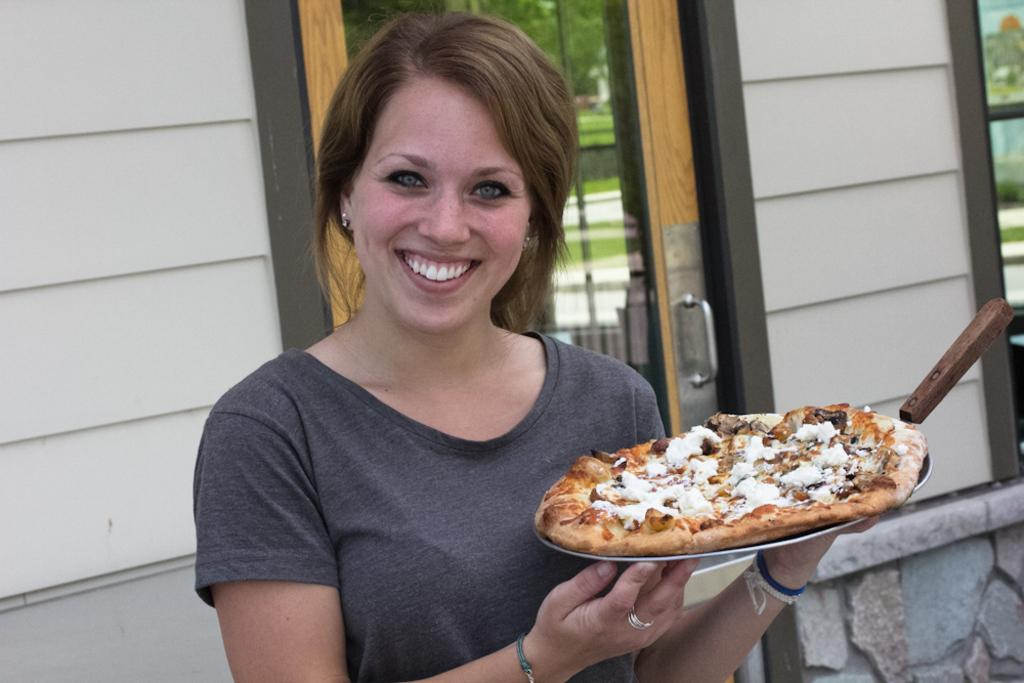What is the main subject of the image? There is a woman in the image. What is the woman doing in the image? The woman is standing and holding a plate with a food item in it. What is the woman's facial expression in the image? The woman is smiling in the image. What can be seen in the background of the image? There is a house wall visible in the image, which has a door and glass in it. What type of whip is the woman using to express her love for the zipper in the image? There is no whip, love, or zipper present in the image. 